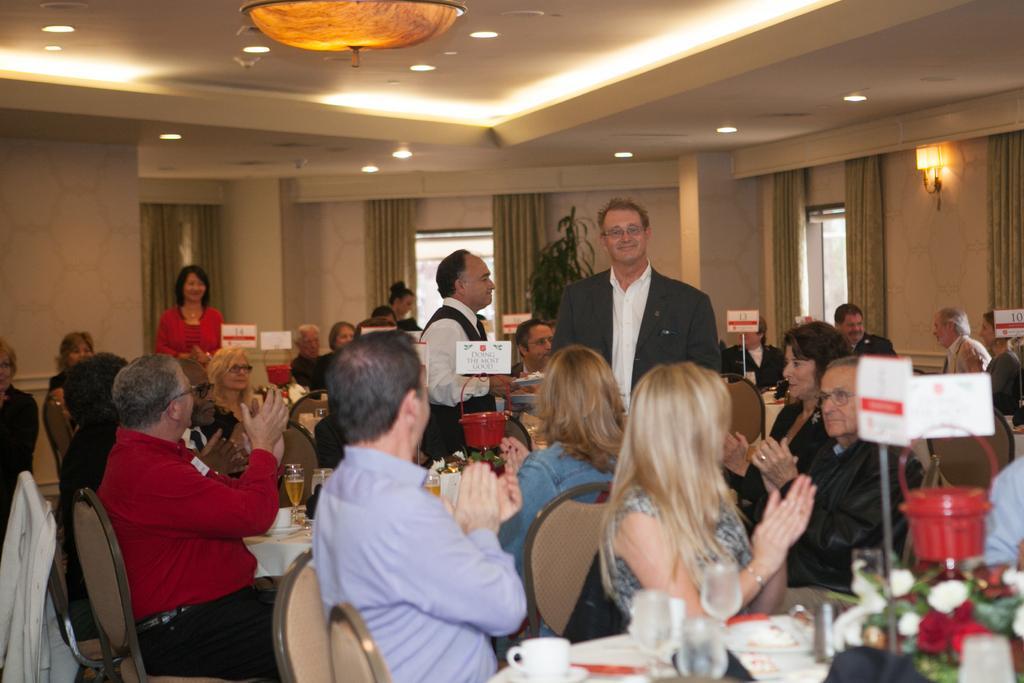Describe this image in one or two sentences. In this picture I can see there is a man standing here and he is wearing a blazer, shirt and spectacles and there is another person standing next to him and there is a woman standing in the backdrop and there are a few people sitting on the chairs and there are tables in front of them and there are wine glasses, flowers, cups and saucers placed on the table. There are lights attached to the ceiling and there is a window in the backdrop and there are curtains. 